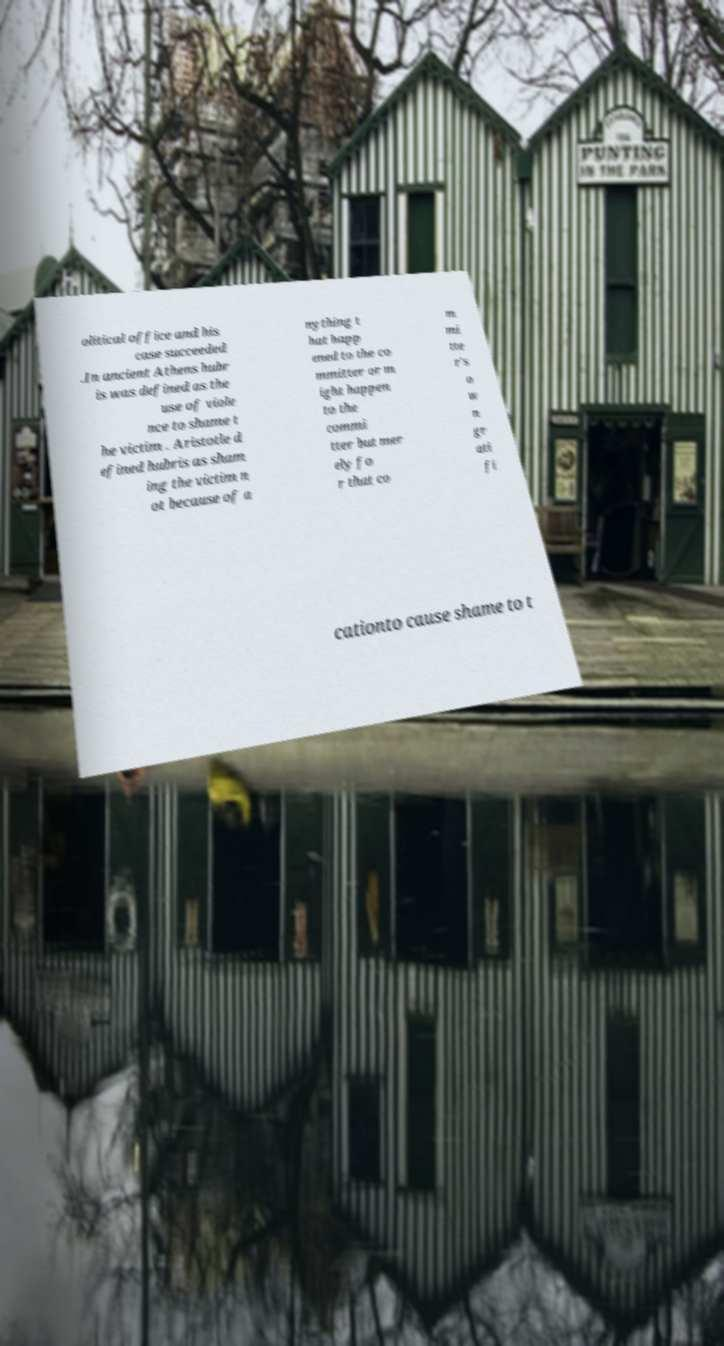Can you accurately transcribe the text from the provided image for me? olitical office and his case succeeded .In ancient Athens hubr is was defined as the use of viole nce to shame t he victim . Aristotle d efined hubris as sham ing the victim n ot because of a nything t hat happ ened to the co mmitter or m ight happen to the commi tter but mer ely fo r that co m mi tte r's o w n gr ati fi cationto cause shame to t 